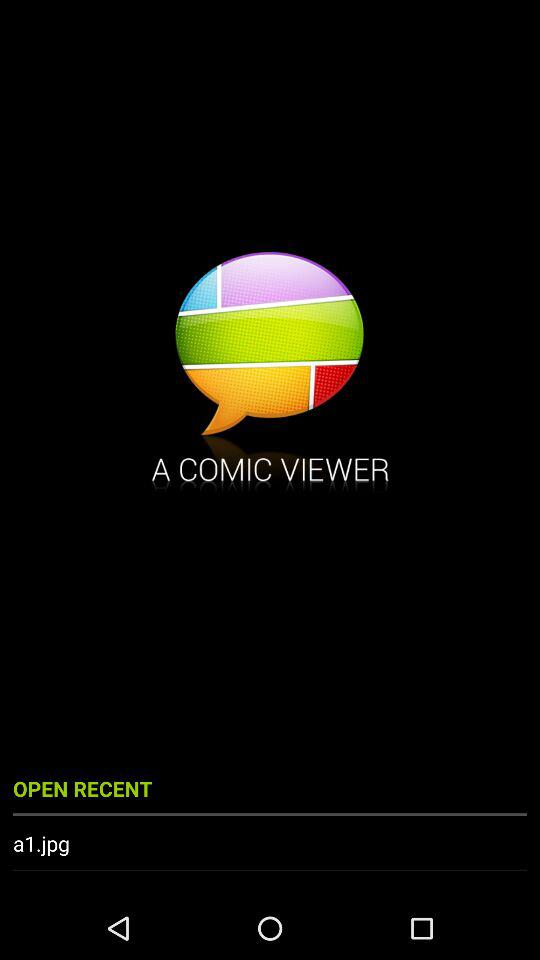What is the application name? The application name is "A COMIC VIEWER". 